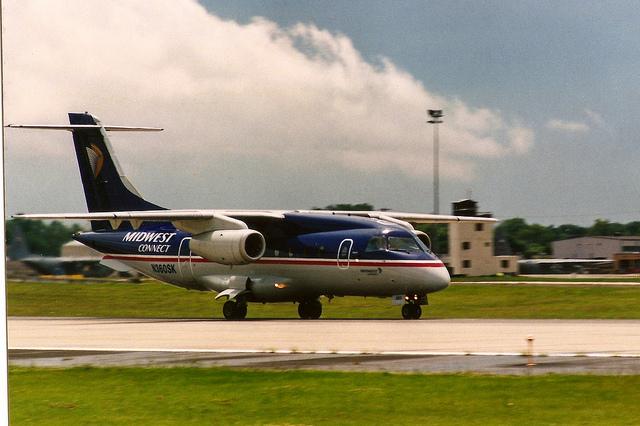What airline is this?
Give a very brief answer. Midwest connect. How many wheels are on the plane?
Short answer required. 3. Are any lights shown in this photo?
Be succinct. No. Is this a helicopter?
Keep it brief. No. 